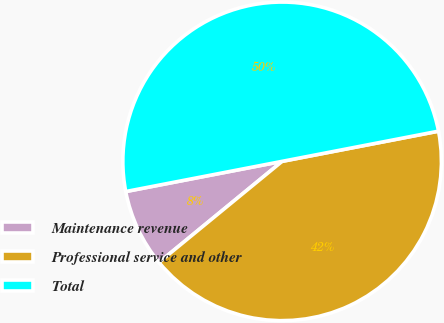Convert chart. <chart><loc_0><loc_0><loc_500><loc_500><pie_chart><fcel>Maintenance revenue<fcel>Professional service and other<fcel>Total<nl><fcel>7.9%<fcel>42.1%<fcel>50.0%<nl></chart> 